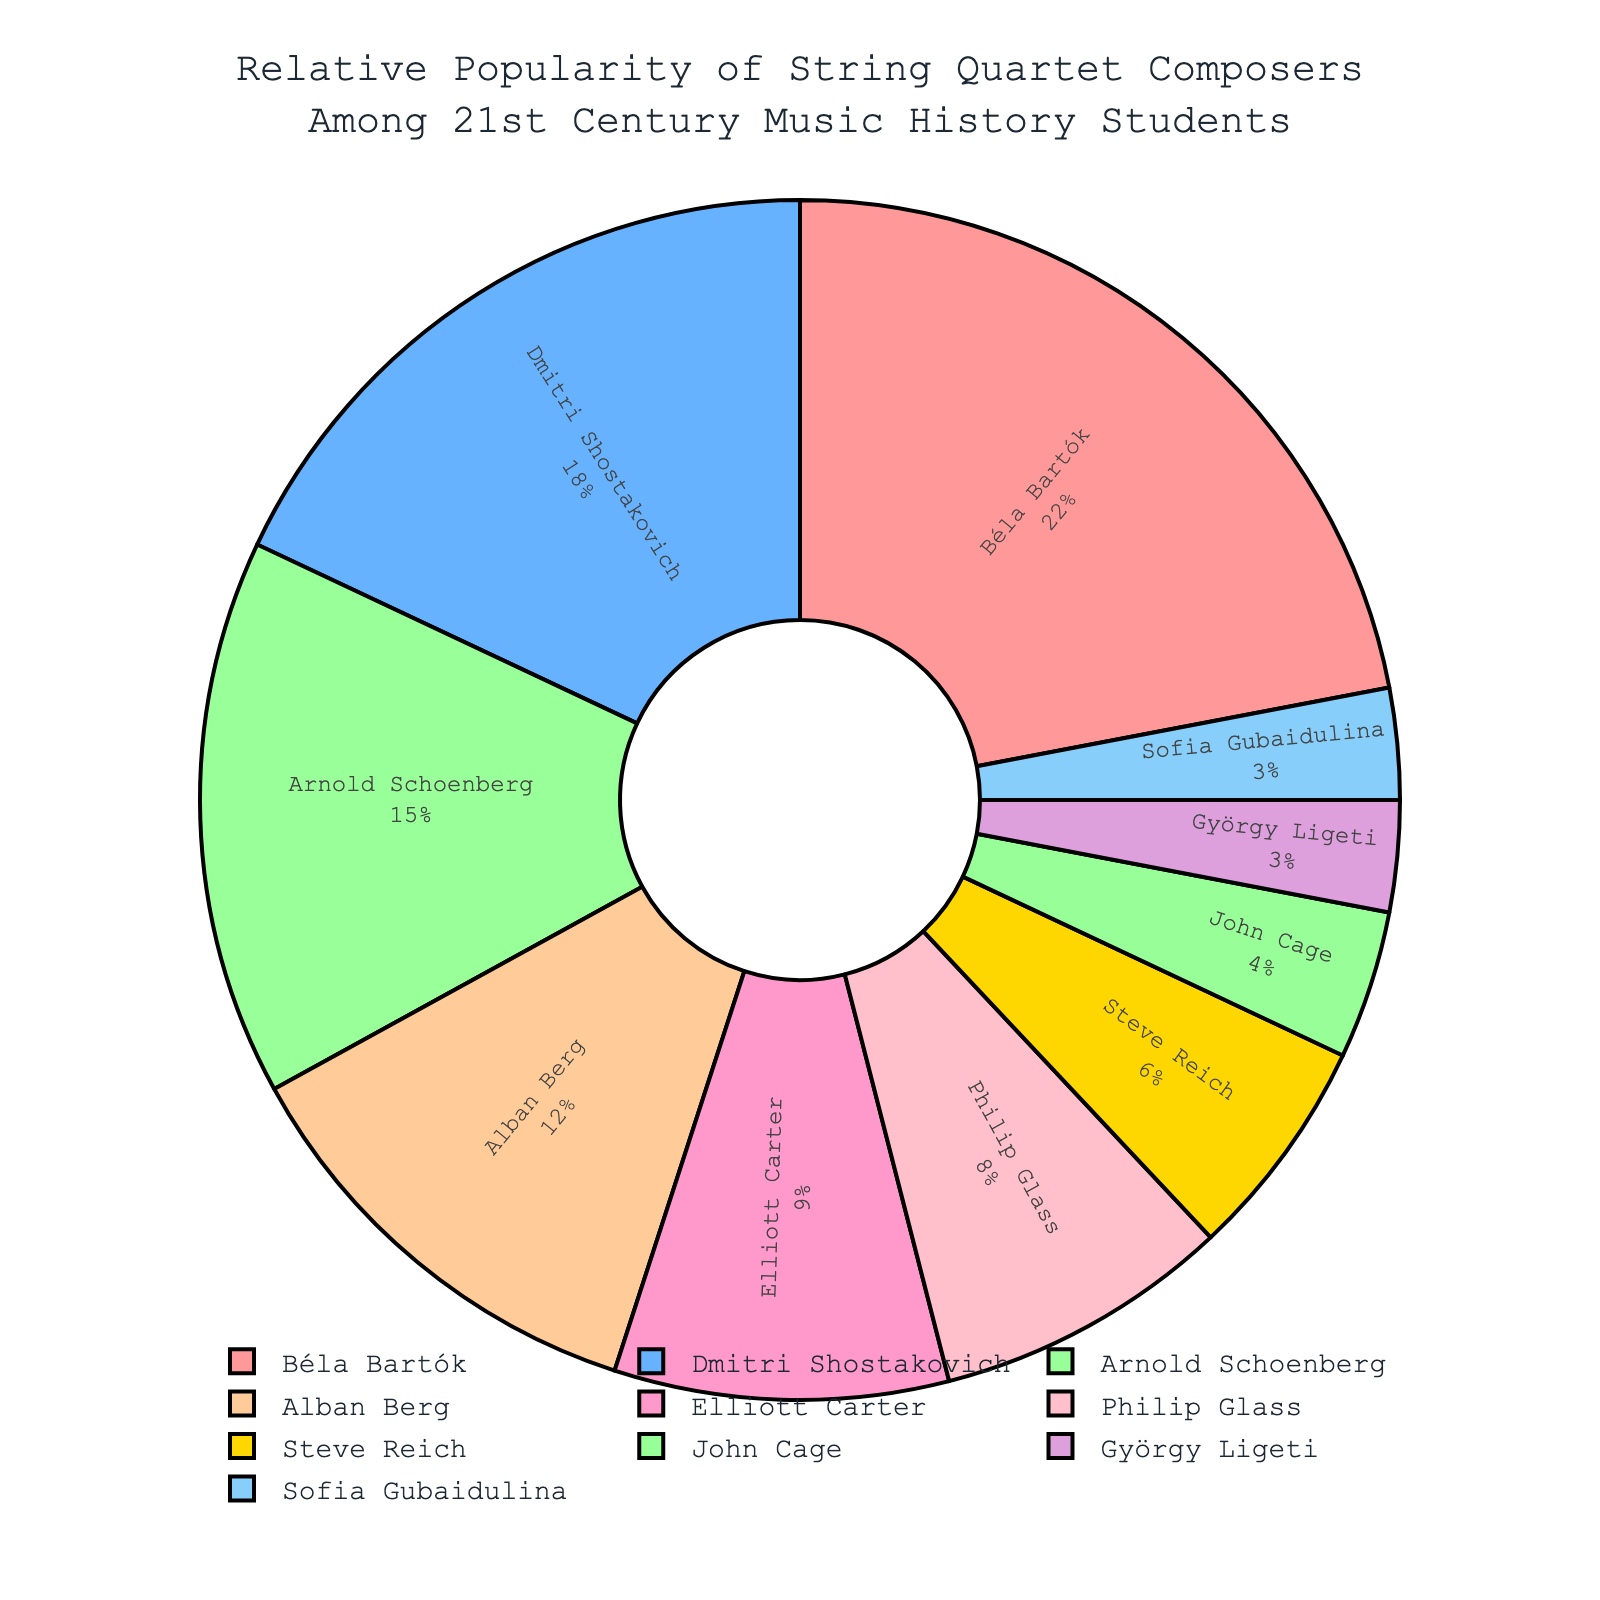Which composer has the highest relative popularity among music history students in the 21st century? From the pie chart, the largest segment corresponds to Béla Bartók, indicating that he has the highest relative popularity with a 22% share.
Answer: Béla Bartók What is the combined relative popularity percentage of Arnold Schoenberg and Alban Berg among music history students in the 21st century? Arnold Schoenberg has a 15% share and Alban Berg has a 12% share. Adding these two percentages gives 15% + 12% = 27%.
Answer: 27% How much more popular is Dmitri Shostakovich than Elliott Carter among music history students in the 21st century? Dmitri Shostakovich has a relative popularity of 18%, while Elliott Carter has 9%. The difference between them is 18% - 9% = 9%.
Answer: 9% Which composers have less than 5% relative popularity? From the pie chart, the segments for John Cage (4%), György Ligeti (3%), and Sofia Gubaidulina (3%) are less than 5%.
Answer: John Cage, György Ligeti, Sofia Gubaidulina What is the relative popularity difference between the least popular composer and the most popular composer? The most popular composer is Béla Bartók with 22%, and the least popular composers are György Ligeti and Sofia Gubaidulina, each with 3%. The difference is 22% - 3% = 19%.
Answer: 19% Is Philip Glass more popular or less popular than Steve Reich among music history students in the 21st century? From the pie chart, Philip Glass has an 8% share, whereas Steve Reich has a 6% share, making Philip Glass more popular than Steve Reich.
Answer: More popular How many composers have a relative popularity of 10% or higher? From the pie chart, the composers with 10% or higher are Béla Bartók (22%), Dmitri Shostakovich (18%), Arnold Schoenberg (15%), and Alban Berg (12%). This totals to 4 composers.
Answer: 4 What is the average relative popularity of composers who have a popularity between 5% and 15%? The composers in this range are Arnold Schoenberg (15%), Alban Berg (12%), Elliott Carter (9%), Philip Glass (8%), and Steve Reich (6%). Adding these percentages gives 15% + 12% + 9% + 8% + 6% = 50%. Dividing by 5 gives an average of 50%/5 = 10%.
Answer: 10% Which segment of the pie chart is represented by the color red? The largest segment, representing Béla Bartók with the highest popularity of 22%, is colored red.
Answer: Béla Bartók 